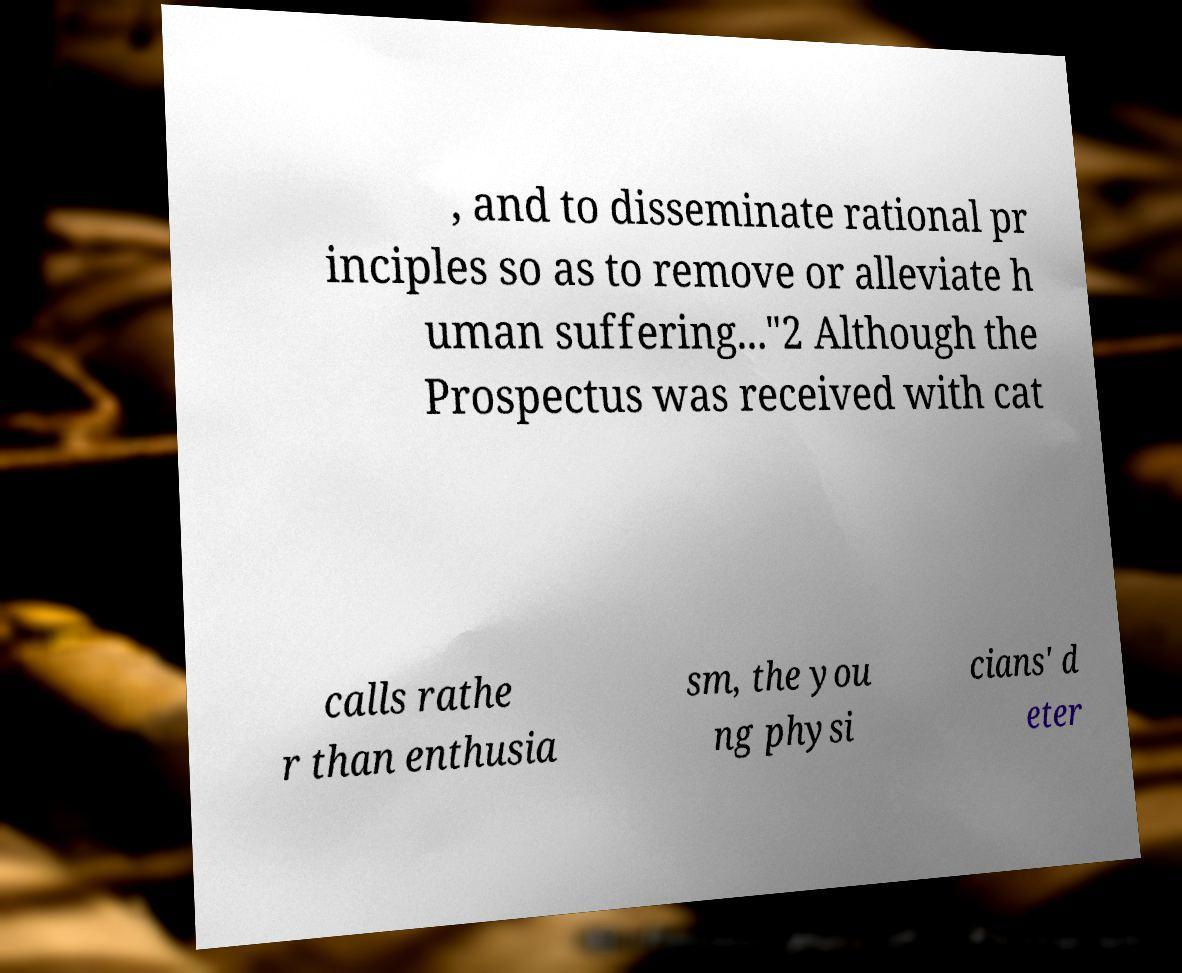Can you read and provide the text displayed in the image?This photo seems to have some interesting text. Can you extract and type it out for me? , and to disseminate rational pr inciples so as to remove or alleviate h uman suffering..."2 Although the Prospectus was received with cat calls rathe r than enthusia sm, the you ng physi cians' d eter 